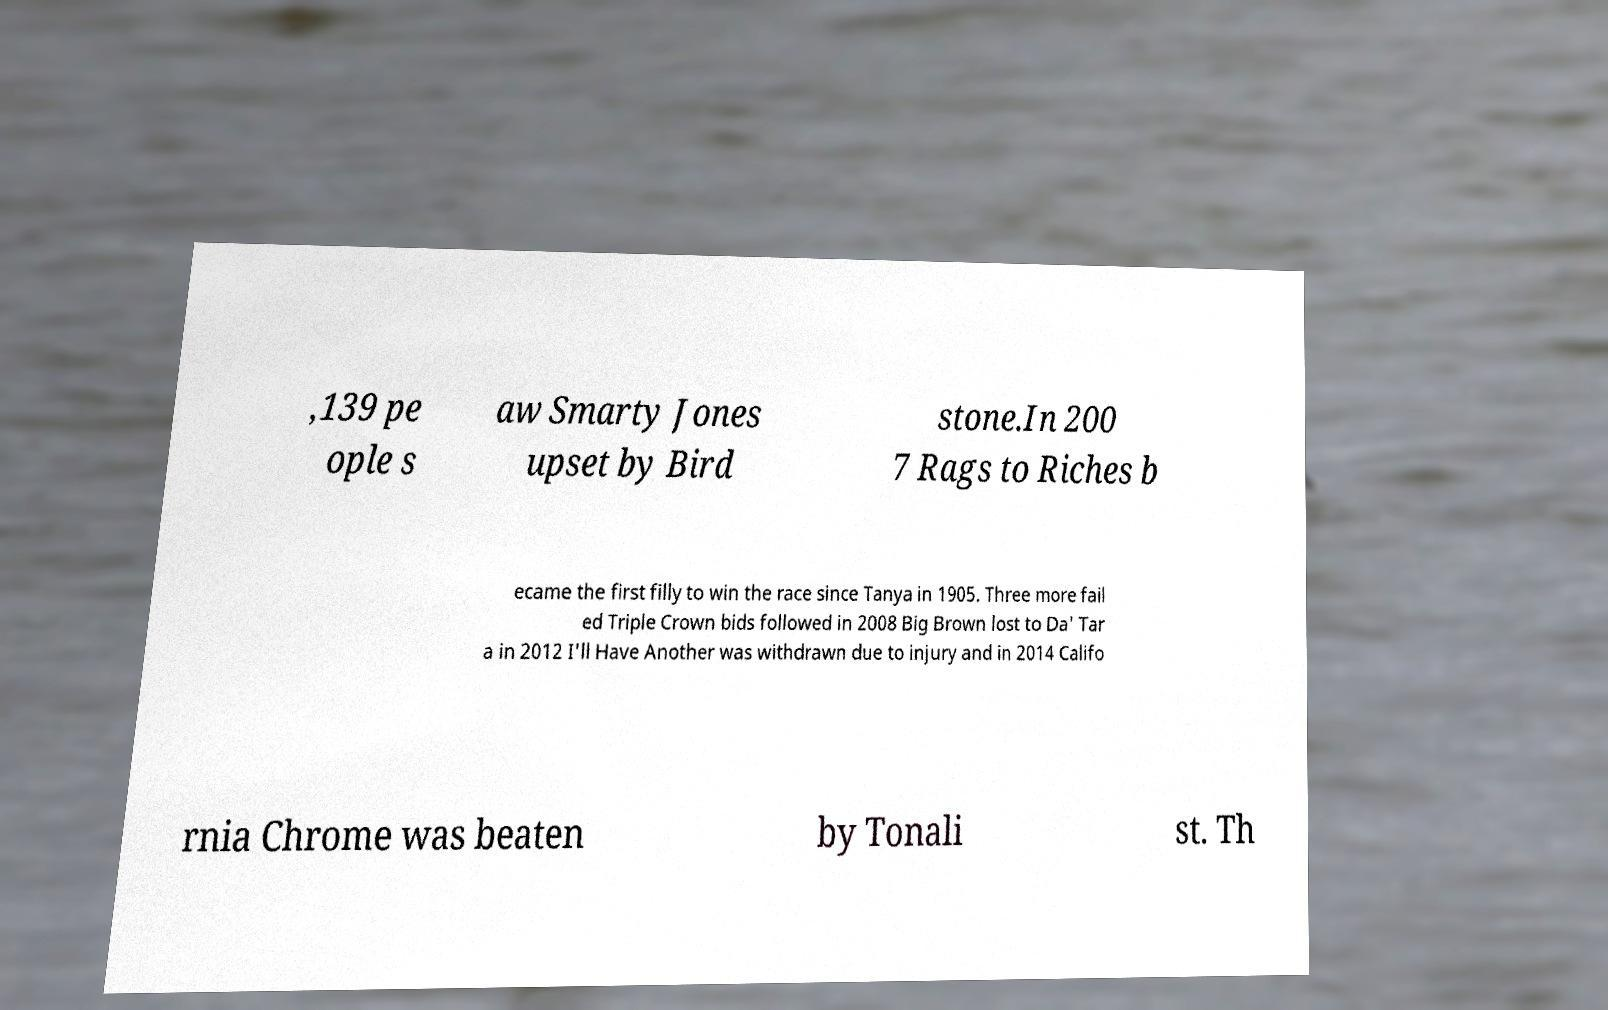There's text embedded in this image that I need extracted. Can you transcribe it verbatim? ,139 pe ople s aw Smarty Jones upset by Bird stone.In 200 7 Rags to Riches b ecame the first filly to win the race since Tanya in 1905. Three more fail ed Triple Crown bids followed in 2008 Big Brown lost to Da' Tar a in 2012 I'll Have Another was withdrawn due to injury and in 2014 Califo rnia Chrome was beaten by Tonali st. Th 